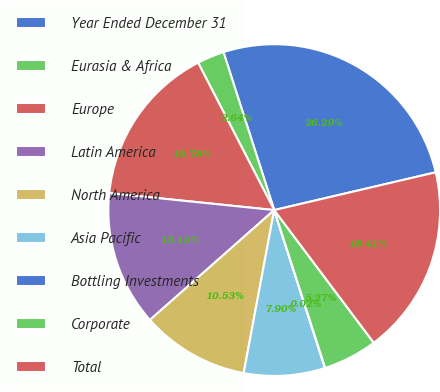<chart> <loc_0><loc_0><loc_500><loc_500><pie_chart><fcel>Year Ended December 31<fcel>Eurasia & Africa<fcel>Europe<fcel>Latin America<fcel>North America<fcel>Asia Pacific<fcel>Bottling Investments<fcel>Corporate<fcel>Total<nl><fcel>26.29%<fcel>2.64%<fcel>15.78%<fcel>13.15%<fcel>10.53%<fcel>7.9%<fcel>0.02%<fcel>5.27%<fcel>18.41%<nl></chart> 